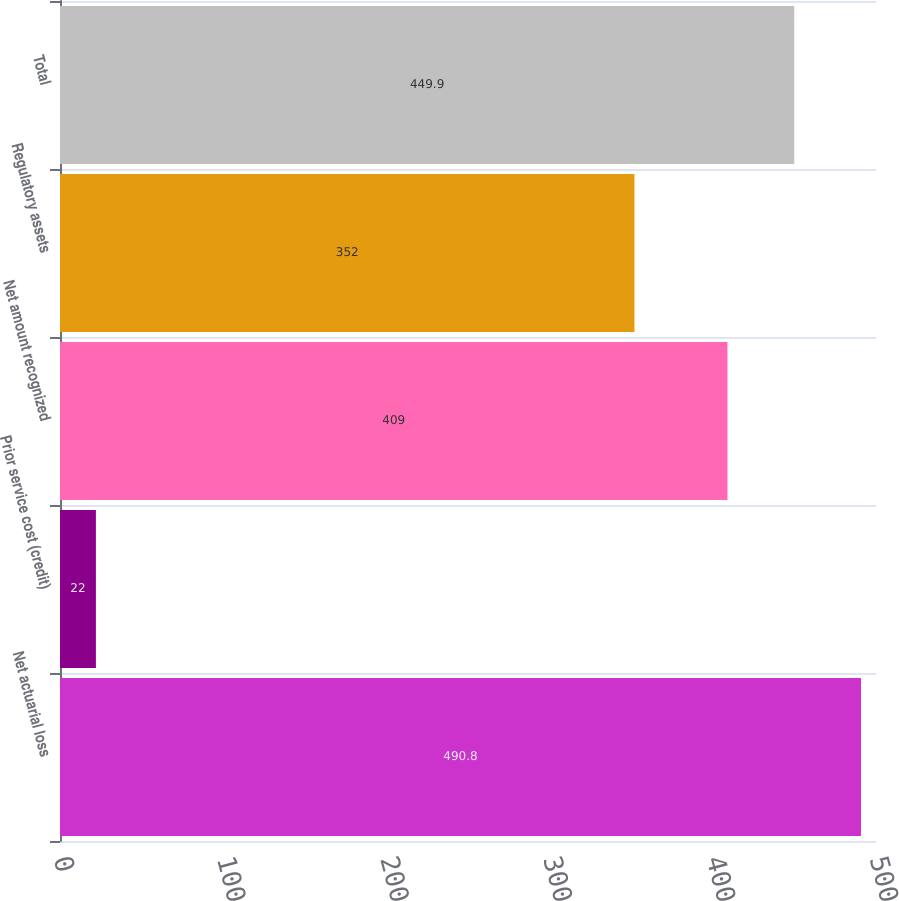Convert chart. <chart><loc_0><loc_0><loc_500><loc_500><bar_chart><fcel>Net actuarial loss<fcel>Prior service cost (credit)<fcel>Net amount recognized<fcel>Regulatory assets<fcel>Total<nl><fcel>490.8<fcel>22<fcel>409<fcel>352<fcel>449.9<nl></chart> 